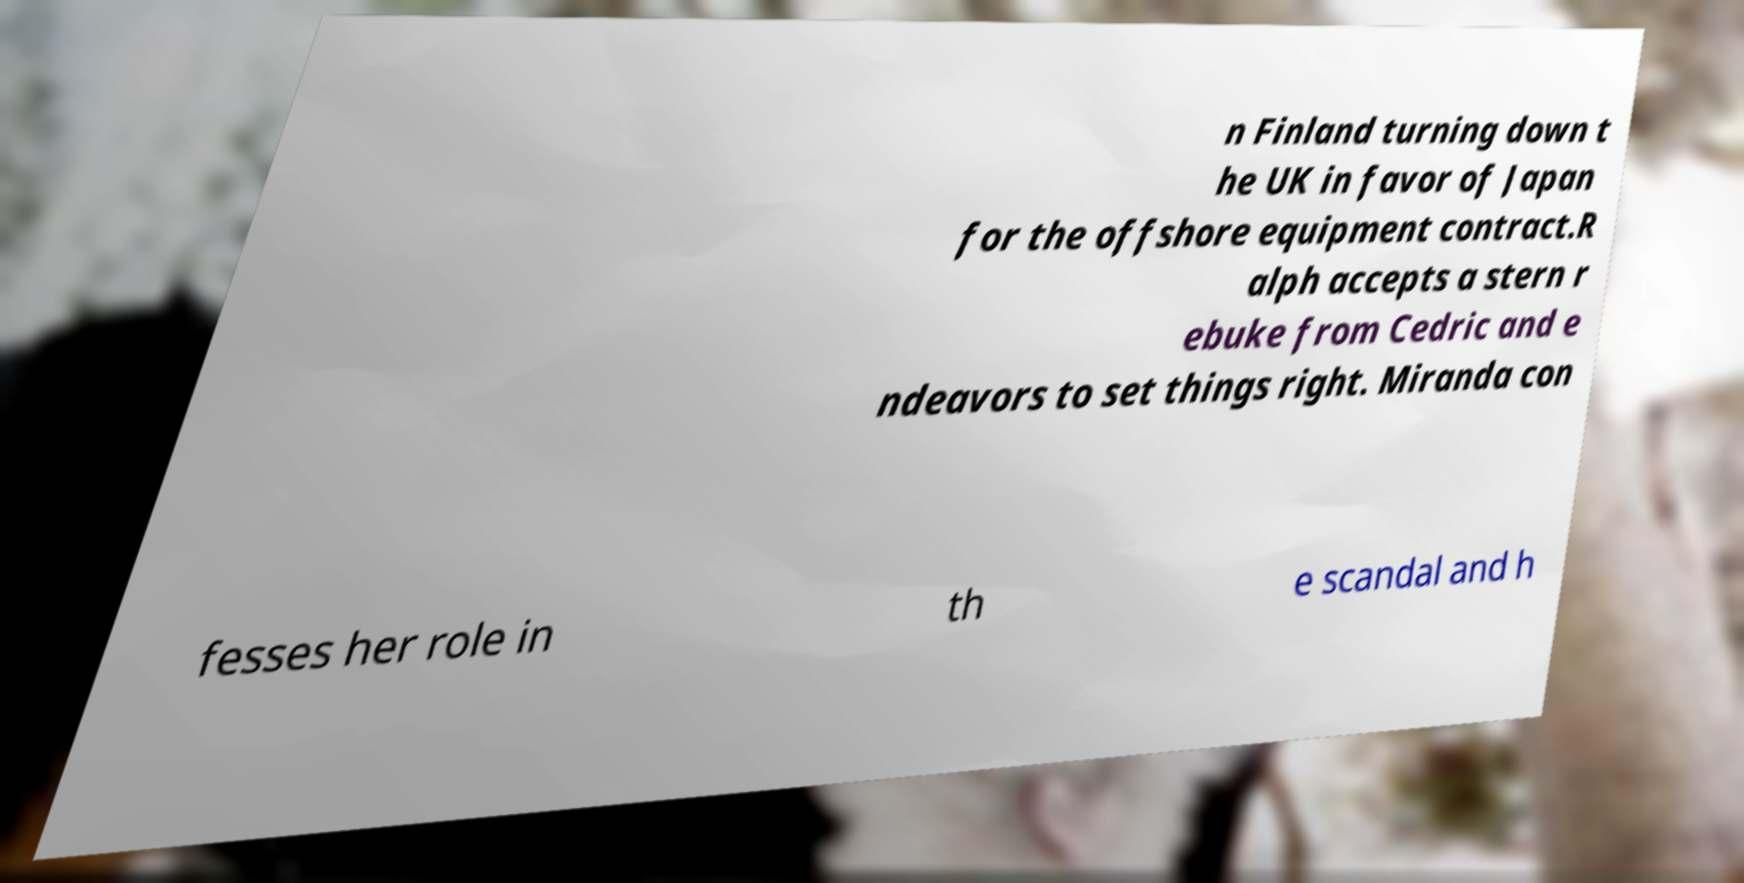Please read and relay the text visible in this image. What does it say? n Finland turning down t he UK in favor of Japan for the offshore equipment contract.R alph accepts a stern r ebuke from Cedric and e ndeavors to set things right. Miranda con fesses her role in th e scandal and h 